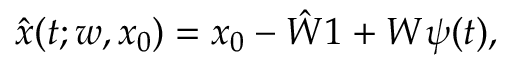Convert formula to latex. <formula><loc_0><loc_0><loc_500><loc_500>\begin{array} { r } { \hat { x } ( t ; w , x _ { 0 } ) = x _ { 0 } - \hat { W } 1 + W \psi ( t ) , } \end{array}</formula> 